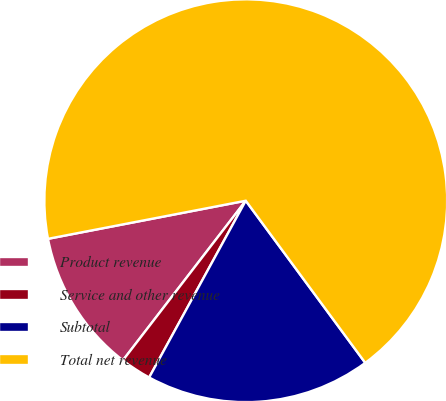<chart> <loc_0><loc_0><loc_500><loc_500><pie_chart><fcel>Product revenue<fcel>Service and other revenue<fcel>Subtotal<fcel>Total net revenue<nl><fcel>11.53%<fcel>2.48%<fcel>18.07%<fcel>67.92%<nl></chart> 